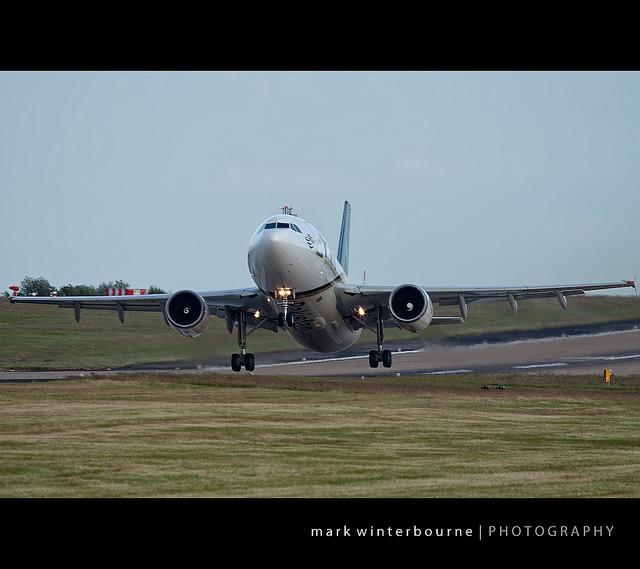Please identify all text content in this image. mark winterbourne PHOTOGRAPHY 